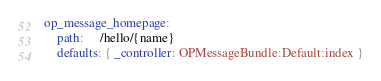<code> <loc_0><loc_0><loc_500><loc_500><_YAML_>op_message_homepage:
    path:     /hello/{name}
    defaults: { _controller: OPMessageBundle:Default:index }
</code> 